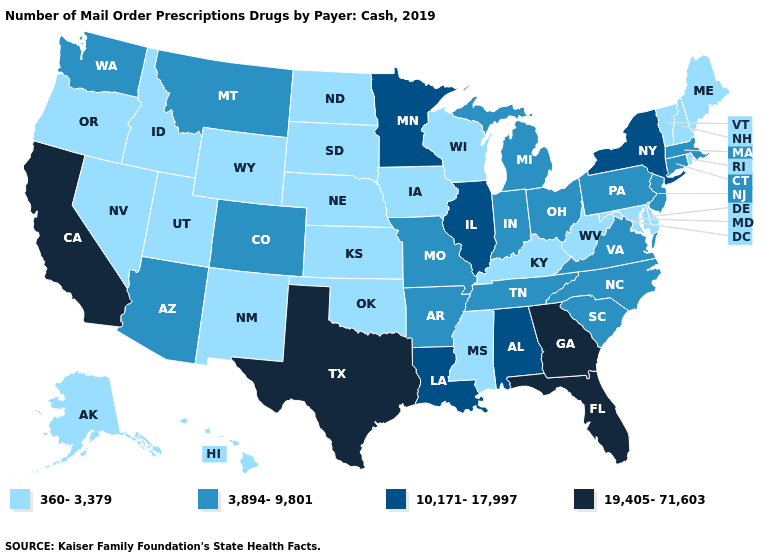Does the first symbol in the legend represent the smallest category?
Give a very brief answer. Yes. Does Minnesota have the highest value in the MidWest?
Short answer required. Yes. What is the lowest value in the MidWest?
Keep it brief. 360-3,379. Does Pennsylvania have the highest value in the USA?
Give a very brief answer. No. Name the states that have a value in the range 360-3,379?
Be succinct. Alaska, Delaware, Hawaii, Idaho, Iowa, Kansas, Kentucky, Maine, Maryland, Mississippi, Nebraska, Nevada, New Hampshire, New Mexico, North Dakota, Oklahoma, Oregon, Rhode Island, South Dakota, Utah, Vermont, West Virginia, Wisconsin, Wyoming. What is the value of Virginia?
Be succinct. 3,894-9,801. What is the value of Nebraska?
Quick response, please. 360-3,379. Does the first symbol in the legend represent the smallest category?
Keep it brief. Yes. Name the states that have a value in the range 360-3,379?
Write a very short answer. Alaska, Delaware, Hawaii, Idaho, Iowa, Kansas, Kentucky, Maine, Maryland, Mississippi, Nebraska, Nevada, New Hampshire, New Mexico, North Dakota, Oklahoma, Oregon, Rhode Island, South Dakota, Utah, Vermont, West Virginia, Wisconsin, Wyoming. Does Alaska have the highest value in the USA?
Keep it brief. No. Does Illinois have the highest value in the MidWest?
Write a very short answer. Yes. What is the lowest value in the South?
Keep it brief. 360-3,379. Which states have the highest value in the USA?
Give a very brief answer. California, Florida, Georgia, Texas. What is the value of Colorado?
Be succinct. 3,894-9,801. What is the value of Maryland?
Quick response, please. 360-3,379. 